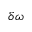<formula> <loc_0><loc_0><loc_500><loc_500>\delta \omega</formula> 